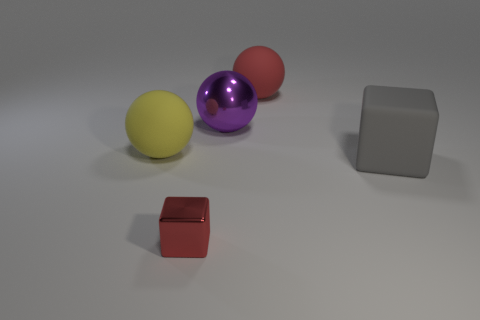Is there any other thing that is the same size as the red metallic cube?
Make the answer very short. No. What number of objects are either shiny blocks left of the gray matte cube or metal objects behind the big gray thing?
Provide a succinct answer. 2. Do the big yellow sphere and the red object behind the red block have the same material?
Your answer should be compact. Yes. The large rubber object that is both on the right side of the tiny metallic thing and to the left of the rubber cube has what shape?
Your answer should be compact. Sphere. How many other objects are the same color as the tiny shiny cube?
Your response must be concise. 1. The yellow thing is what shape?
Your response must be concise. Sphere. There is a big object that is right of the matte thing that is behind the yellow ball; what color is it?
Offer a terse response. Gray. Do the large metal ball and the cube left of the big gray cube have the same color?
Make the answer very short. No. What is the large ball that is both in front of the red matte object and on the right side of the yellow sphere made of?
Make the answer very short. Metal. Are there any purple objects that have the same size as the metallic block?
Make the answer very short. No. 